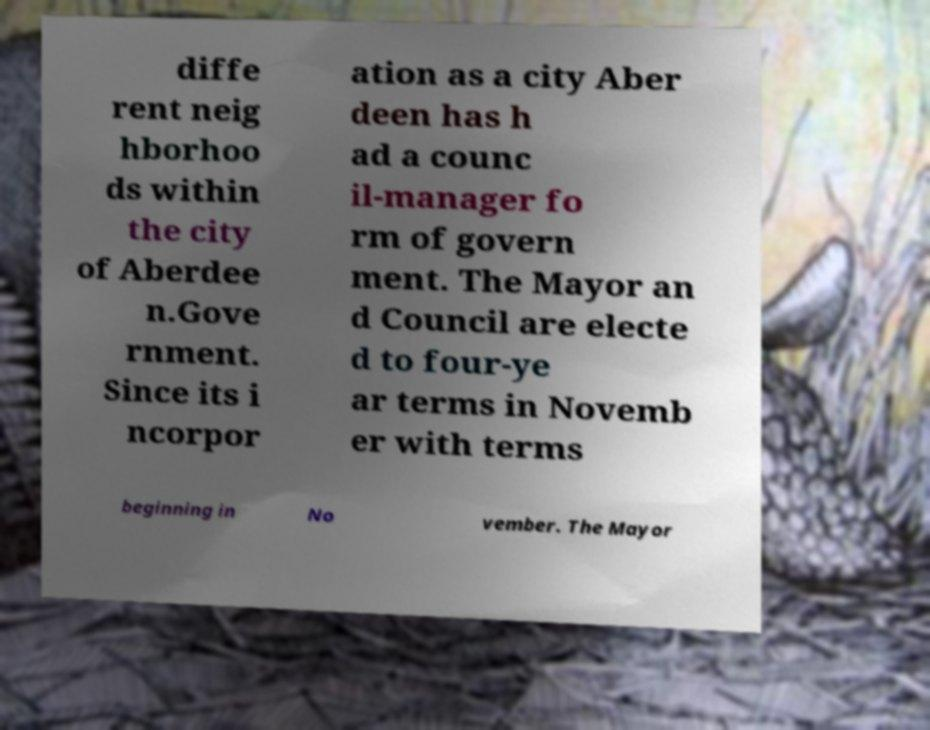There's text embedded in this image that I need extracted. Can you transcribe it verbatim? diffe rent neig hborhoo ds within the city of Aberdee n.Gove rnment. Since its i ncorpor ation as a city Aber deen has h ad a counc il-manager fo rm of govern ment. The Mayor an d Council are electe d to four-ye ar terms in Novemb er with terms beginning in No vember. The Mayor 